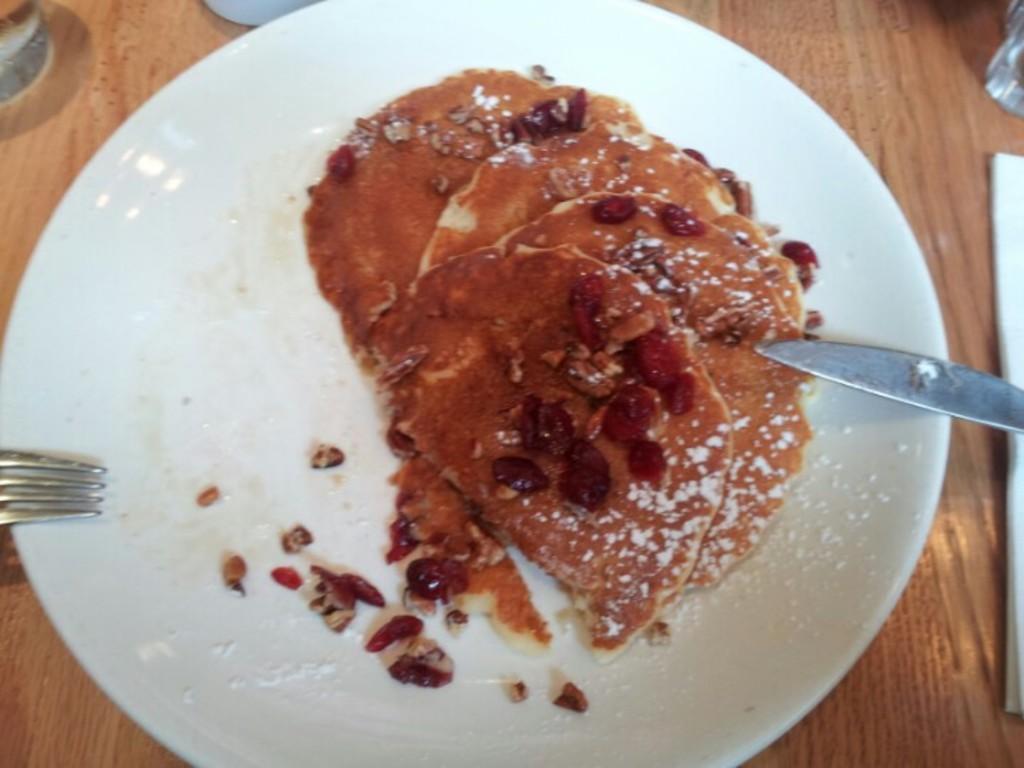Describe this image in one or two sentences. In this image there is a food item on a plate, beside the plate there is a knife and a fork, the plate is on top of a table. 